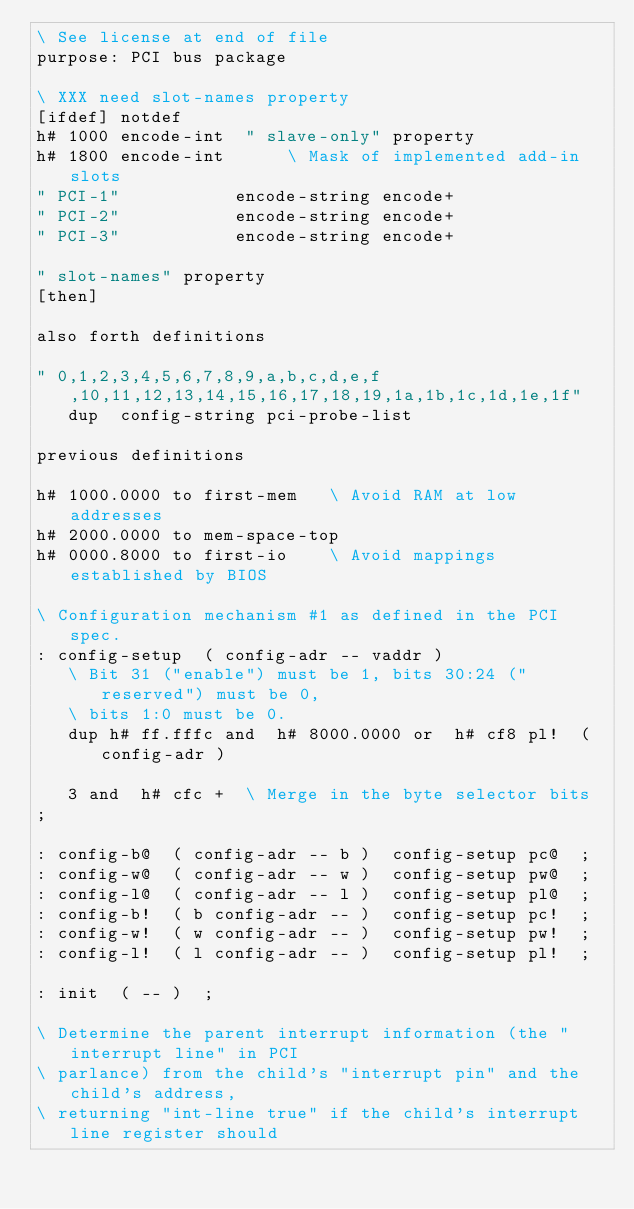<code> <loc_0><loc_0><loc_500><loc_500><_Forth_>\ See license at end of file
purpose: PCI bus package

\ XXX need slot-names property
[ifdef] notdef
h# 1000 encode-int  " slave-only" property
h# 1800 encode-int			\ Mask of implemented add-in slots
" PCI-1"           encode-string encode+
" PCI-2"           encode-string encode+
" PCI-3"           encode-string encode+

" slot-names" property
[then]

also forth definitions

" 0,1,2,3,4,5,6,7,8,9,a,b,c,d,e,f,10,11,12,13,14,15,16,17,18,19,1a,1b,1c,1d,1e,1f"
   dup  config-string pci-probe-list

previous definitions

h# 1000.0000 to first-mem		\ Avoid RAM at low addresses
h# 2000.0000 to mem-space-top
h# 0000.8000 to first-io		\ Avoid mappings established by BIOS

\ Configuration mechanism #1 as defined in the PCI spec.
: config-setup  ( config-adr -- vaddr )
   \ Bit 31 ("enable") must be 1, bits 30:24 ("reserved") must be 0,
   \ bits 1:0 must be 0.
   dup h# ff.fffc and  h# 8000.0000 or  h# cf8 pl!  ( config-adr )

   3 and  h# cfc +  \ Merge in the byte selector bits
;

: config-b@  ( config-adr -- b )  config-setup pc@  ;
: config-w@  ( config-adr -- w )  config-setup pw@  ;
: config-l@  ( config-adr -- l )  config-setup pl@  ;
: config-b!  ( b config-adr -- )  config-setup pc!  ;
: config-w!  ( w config-adr -- )  config-setup pw!  ;
: config-l!  ( l config-adr -- )  config-setup pl!  ;

: init  ( -- )  ;

\ Determine the parent interrupt information (the "interrupt line" in PCI
\ parlance) from the child's "interrupt pin" and the child's address,
\ returning "int-line true" if the child's interrupt line register should</code> 